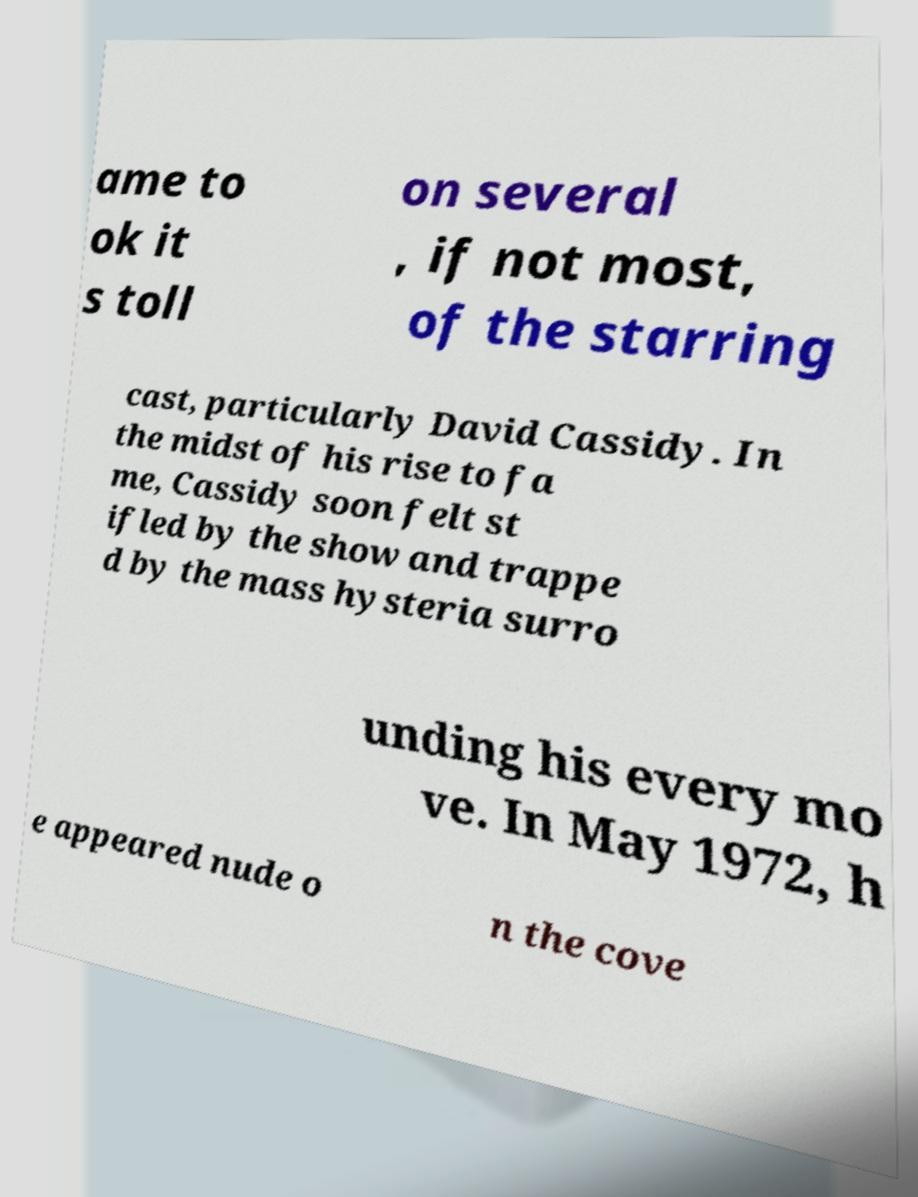Please read and relay the text visible in this image. What does it say? ame to ok it s toll on several , if not most, of the starring cast, particularly David Cassidy. In the midst of his rise to fa me, Cassidy soon felt st ifled by the show and trappe d by the mass hysteria surro unding his every mo ve. In May 1972, h e appeared nude o n the cove 